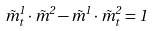Convert formula to latex. <formula><loc_0><loc_0><loc_500><loc_500>\vec { m } ^ { 1 } _ { t } \cdot \vec { m } ^ { 2 } - \vec { m } ^ { 1 } \cdot \vec { m } ^ { 2 } _ { t } = 1</formula> 